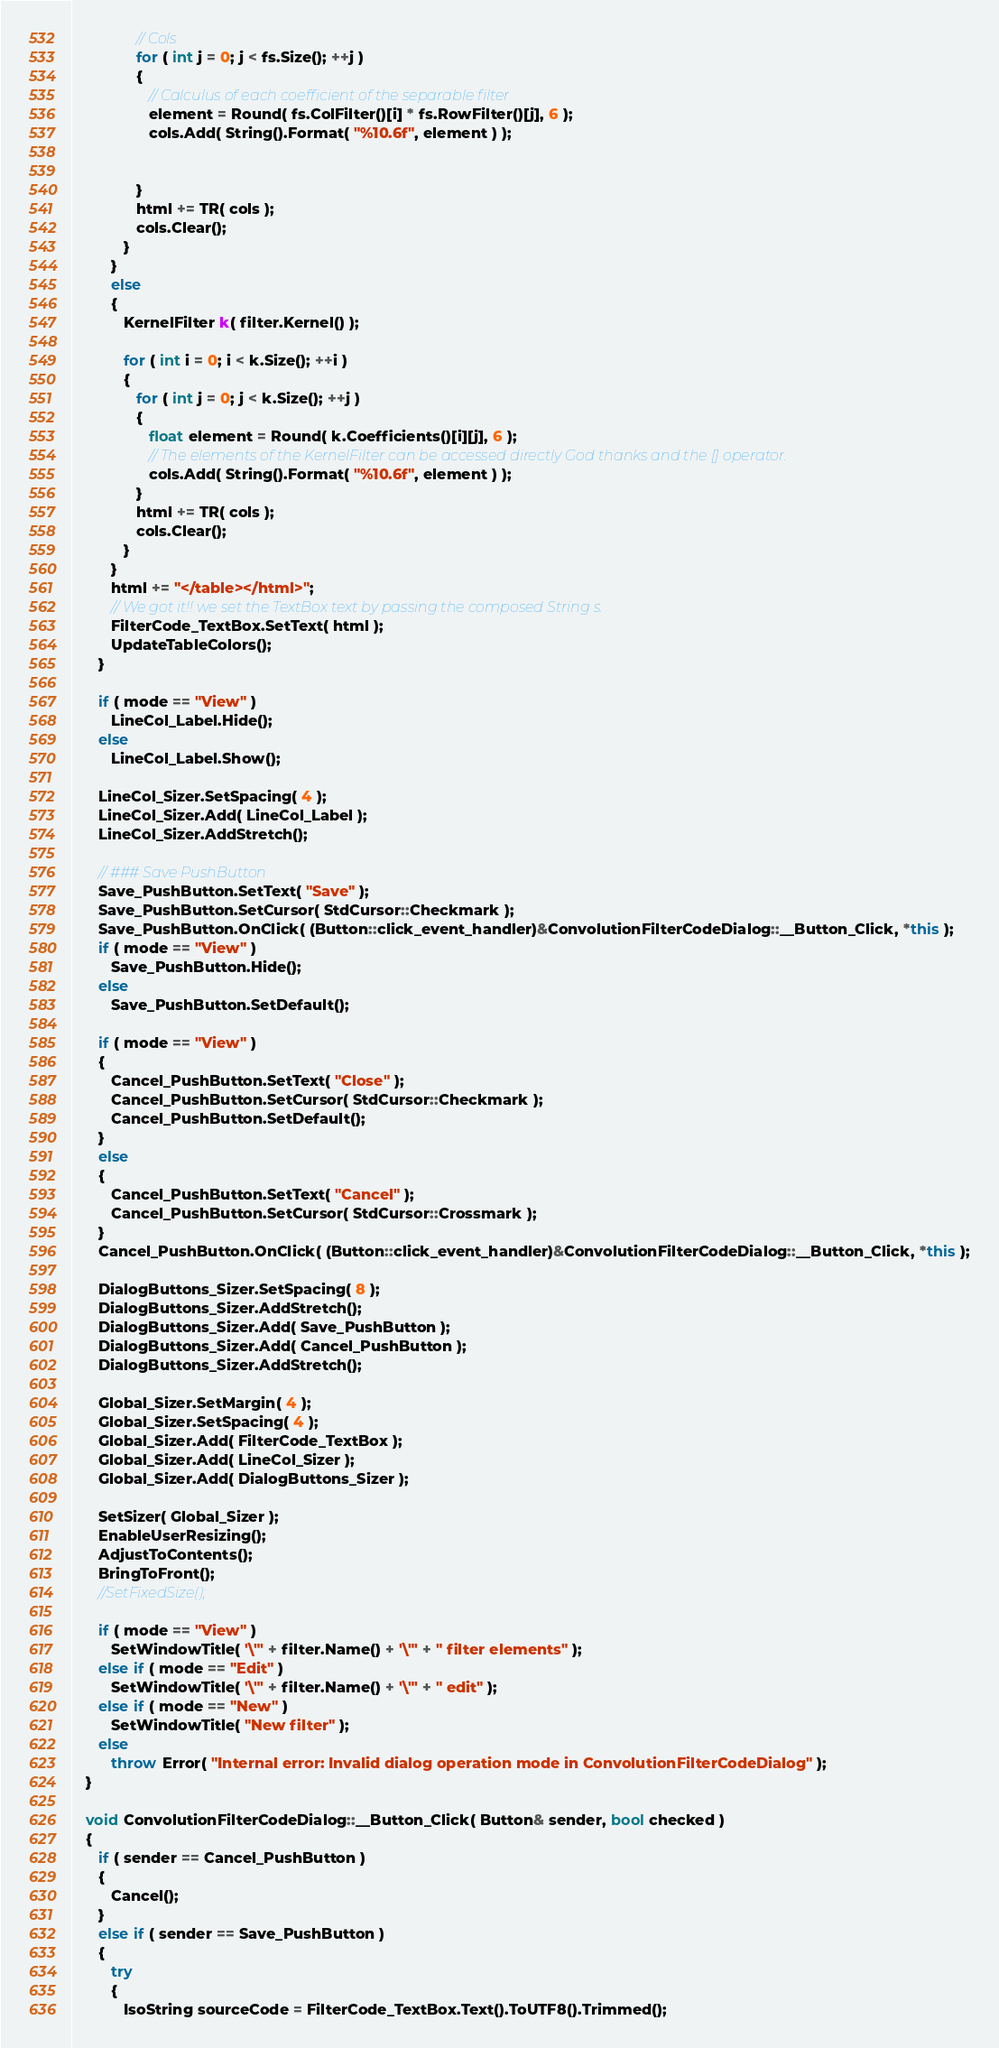Convert code to text. <code><loc_0><loc_0><loc_500><loc_500><_C++_>               // Cols
               for ( int j = 0; j < fs.Size(); ++j )
               {
                  // Calculus of each coefficient of the separable filter
                  element = Round( fs.ColFilter()[i] * fs.RowFilter()[j], 6 );
                  cols.Add( String().Format( "%10.6f", element ) );


               }
               html += TR( cols );
               cols.Clear();
            }
         }
         else
         {
            KernelFilter k( filter.Kernel() );

            for ( int i = 0; i < k.Size(); ++i )
            {
               for ( int j = 0; j < k.Size(); ++j )
               {
                  float element = Round( k.Coefficients()[i][j], 6 );
                  // The elements of the KernelFilter can be accessed directly God thanks and the [] operator.
                  cols.Add( String().Format( "%10.6f", element ) );
               }
               html += TR( cols );
               cols.Clear();
            }
         }
         html += "</table></html>";
         // We got it!! we set the TextBox text by passing the composed String s.
         FilterCode_TextBox.SetText( html );
         UpdateTableColors();
      }

      if ( mode == "View" )
         LineCol_Label.Hide();
      else
         LineCol_Label.Show();

      LineCol_Sizer.SetSpacing( 4 );
      LineCol_Sizer.Add( LineCol_Label );
      LineCol_Sizer.AddStretch();

      // ### Save PushButton
      Save_PushButton.SetText( "Save" );
      Save_PushButton.SetCursor( StdCursor::Checkmark );
      Save_PushButton.OnClick( (Button::click_event_handler)&ConvolutionFilterCodeDialog::__Button_Click, *this );
      if ( mode == "View" )
         Save_PushButton.Hide();
      else
         Save_PushButton.SetDefault();

      if ( mode == "View" )
      {
         Cancel_PushButton.SetText( "Close" );
         Cancel_PushButton.SetCursor( StdCursor::Checkmark );
         Cancel_PushButton.SetDefault();
      }
      else
      {
         Cancel_PushButton.SetText( "Cancel" );
         Cancel_PushButton.SetCursor( StdCursor::Crossmark );
      }
      Cancel_PushButton.OnClick( (Button::click_event_handler)&ConvolutionFilterCodeDialog::__Button_Click, *this );

      DialogButtons_Sizer.SetSpacing( 8 );
      DialogButtons_Sizer.AddStretch();
      DialogButtons_Sizer.Add( Save_PushButton );
      DialogButtons_Sizer.Add( Cancel_PushButton );
      DialogButtons_Sizer.AddStretch();

      Global_Sizer.SetMargin( 4 );
      Global_Sizer.SetSpacing( 4 );
      Global_Sizer.Add( FilterCode_TextBox );
      Global_Sizer.Add( LineCol_Sizer );
      Global_Sizer.Add( DialogButtons_Sizer );

      SetSizer( Global_Sizer );
      EnableUserResizing();
      AdjustToContents();
      BringToFront();
      //SetFixedSize();

      if ( mode == "View" )
         SetWindowTitle( '\"' + filter.Name() + '\"' + " filter elements" );
      else if ( mode == "Edit" )
         SetWindowTitle( '\"' + filter.Name() + '\"' + " edit" );
      else if ( mode == "New" )
         SetWindowTitle( "New filter" );
      else
         throw Error( "Internal error: Invalid dialog operation mode in ConvolutionFilterCodeDialog" );
   }

   void ConvolutionFilterCodeDialog::__Button_Click( Button& sender, bool checked )
   {
      if ( sender == Cancel_PushButton )
      {
         Cancel();
      }
      else if ( sender == Save_PushButton )
      {
         try
         {
            IsoString sourceCode = FilterCode_TextBox.Text().ToUTF8().Trimmed();</code> 